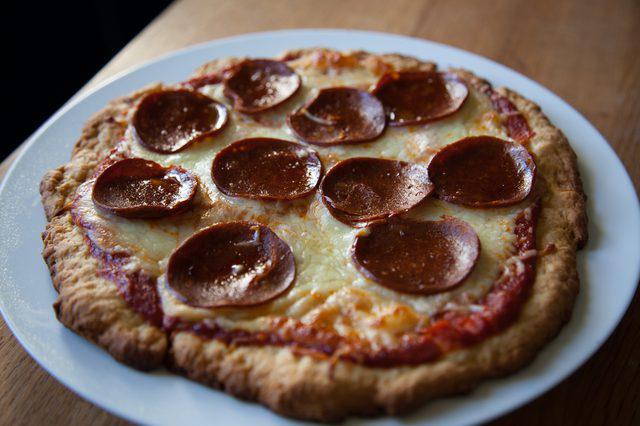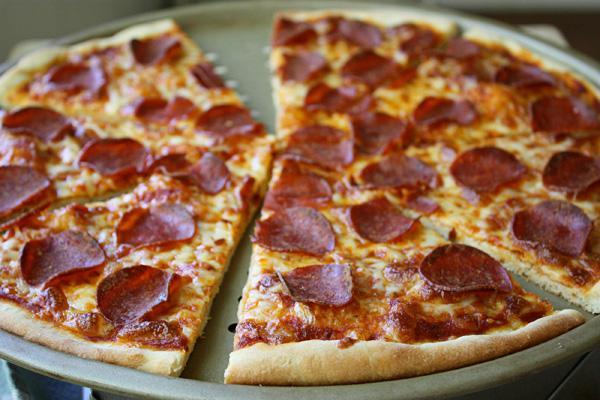The first image is the image on the left, the second image is the image on the right. Evaluate the accuracy of this statement regarding the images: "In the left image, there is more than one individual pizza.". Is it true? Answer yes or no. No. 